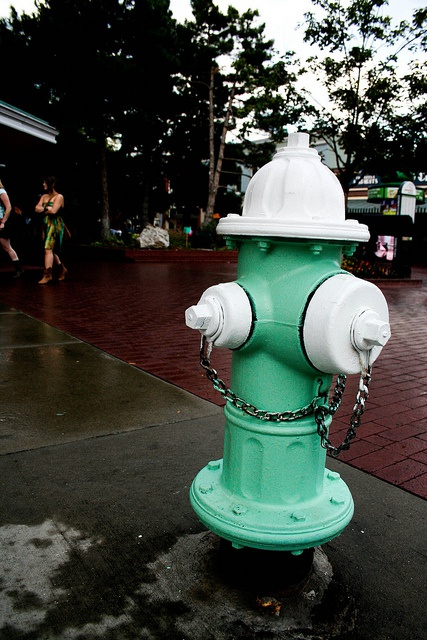Describe the objects in this image and their specific colors. I can see fire hydrant in white, lightgray, turquoise, black, and teal tones, people in white, black, maroon, brown, and olive tones, people in white, black, brown, and maroon tones, and people in white, black, maroon, brown, and violet tones in this image. 